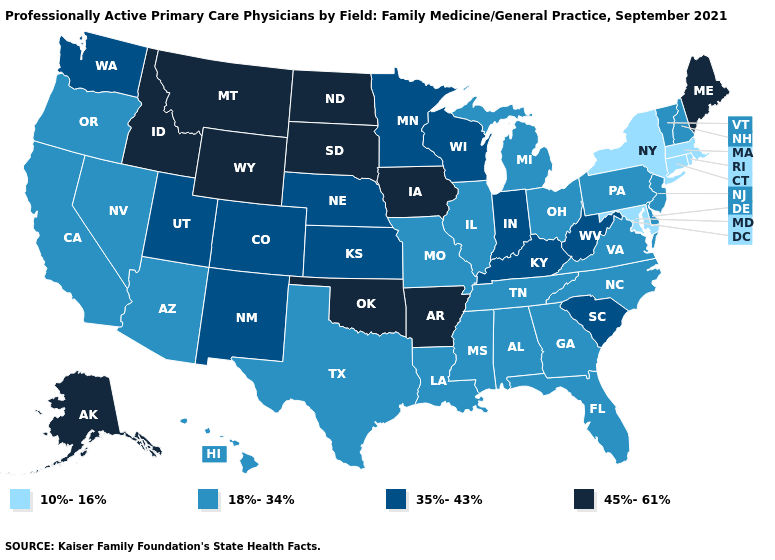Among the states that border Wyoming , which have the highest value?
Concise answer only. Idaho, Montana, South Dakota. How many symbols are there in the legend?
Keep it brief. 4. What is the value of Michigan?
Write a very short answer. 18%-34%. Name the states that have a value in the range 18%-34%?
Short answer required. Alabama, Arizona, California, Delaware, Florida, Georgia, Hawaii, Illinois, Louisiana, Michigan, Mississippi, Missouri, Nevada, New Hampshire, New Jersey, North Carolina, Ohio, Oregon, Pennsylvania, Tennessee, Texas, Vermont, Virginia. Which states have the highest value in the USA?
Answer briefly. Alaska, Arkansas, Idaho, Iowa, Maine, Montana, North Dakota, Oklahoma, South Dakota, Wyoming. Name the states that have a value in the range 35%-43%?
Short answer required. Colorado, Indiana, Kansas, Kentucky, Minnesota, Nebraska, New Mexico, South Carolina, Utah, Washington, West Virginia, Wisconsin. What is the value of Tennessee?
Answer briefly. 18%-34%. What is the lowest value in states that border Kansas?
Write a very short answer. 18%-34%. Does Delaware have the same value as Maryland?
Concise answer only. No. Does Virginia have the lowest value in the USA?
Concise answer only. No. Which states have the lowest value in the MidWest?
Answer briefly. Illinois, Michigan, Missouri, Ohio. What is the lowest value in states that border New Jersey?
Write a very short answer. 10%-16%. Does Maine have the highest value in the Northeast?
Be succinct. Yes. Name the states that have a value in the range 18%-34%?
Write a very short answer. Alabama, Arizona, California, Delaware, Florida, Georgia, Hawaii, Illinois, Louisiana, Michigan, Mississippi, Missouri, Nevada, New Hampshire, New Jersey, North Carolina, Ohio, Oregon, Pennsylvania, Tennessee, Texas, Vermont, Virginia. Name the states that have a value in the range 35%-43%?
Quick response, please. Colorado, Indiana, Kansas, Kentucky, Minnesota, Nebraska, New Mexico, South Carolina, Utah, Washington, West Virginia, Wisconsin. 